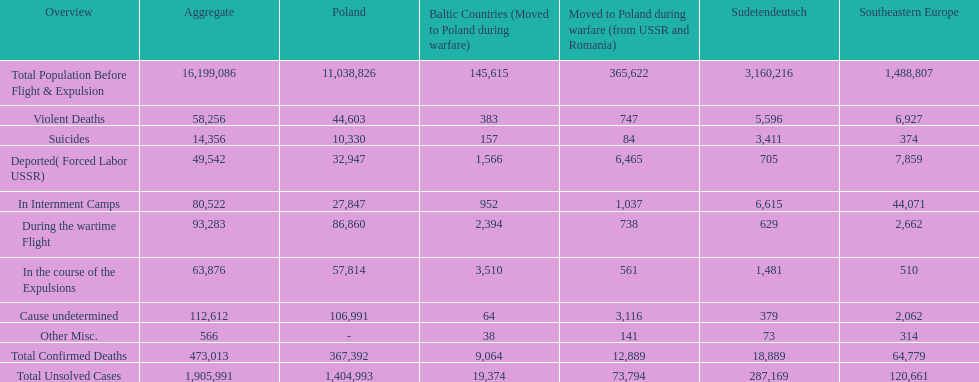How many causes were responsible for more than 50,000 confirmed deaths? 5. 